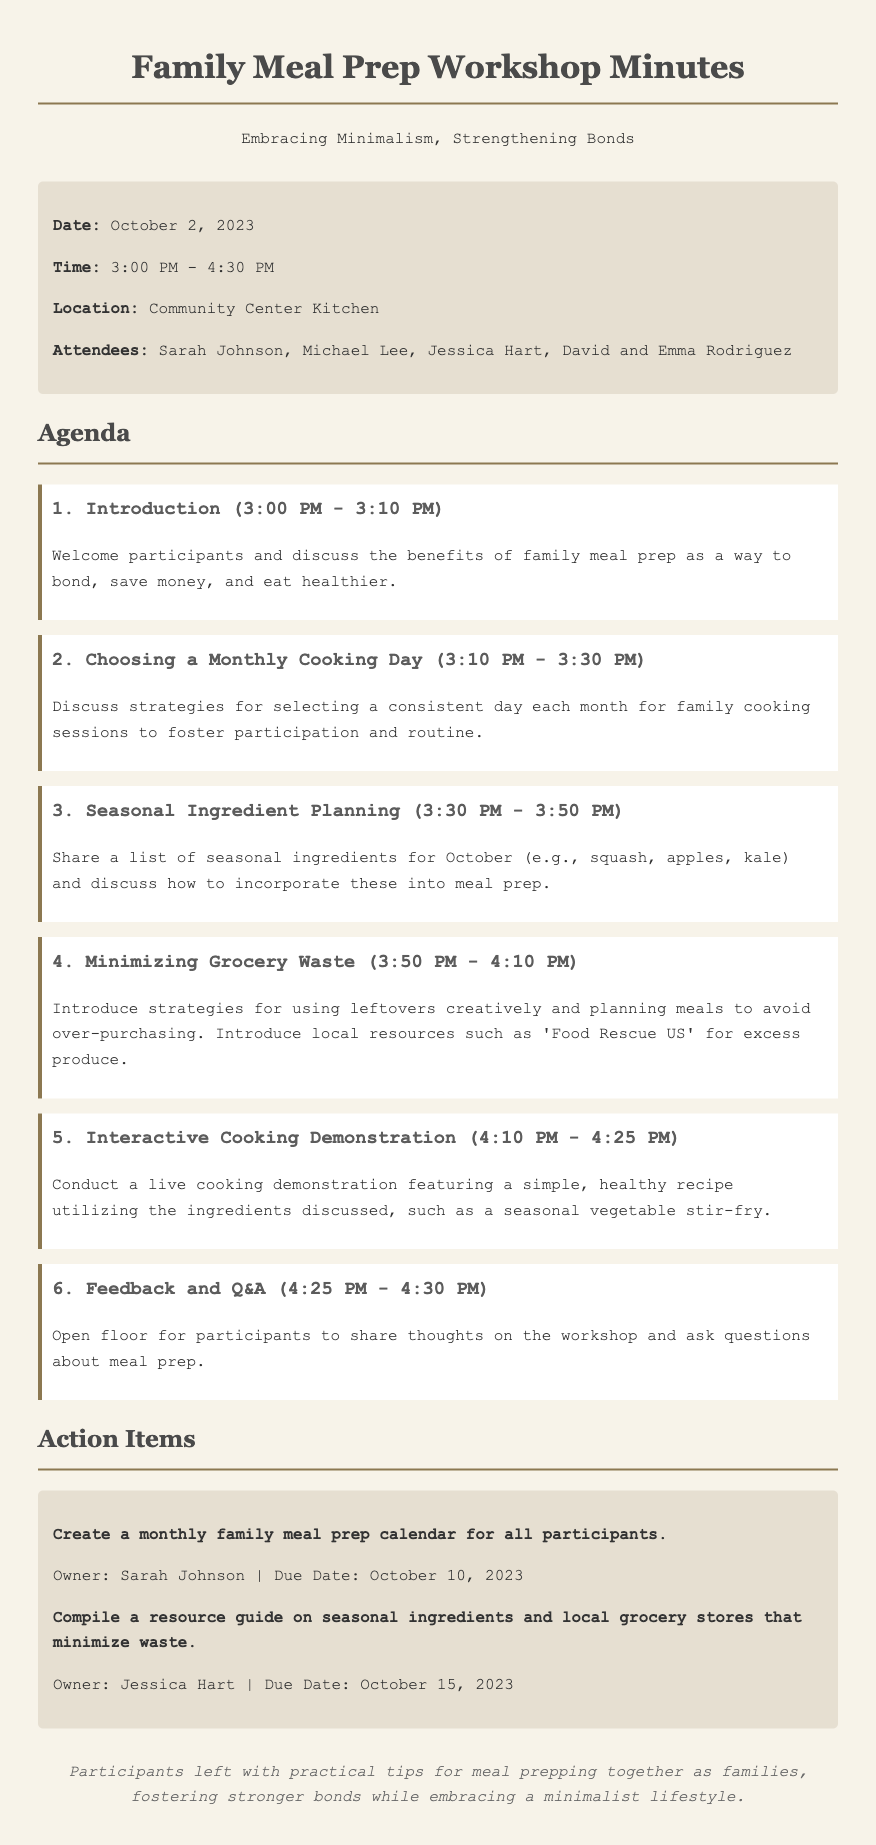what is the date of the workshop? The date of the workshop is provided in the document under the info section.
Answer: October 2, 2023 who is the owner of the action item to create a monthly family meal prep calendar? The owner of the action item is specified in the action items section.
Answer: Sarah Johnson what is one seasonal ingredient mentioned for October? The document lists seasonal ingredients during the seasonal ingredient planning agenda item.
Answer: Squash what time does the interactive cooking demonstration begin? The start time is indicated under the agenda item for the cooking demonstration.
Answer: 4:10 PM how many attendees were present at the workshop? The number of attendees is listed under the info section of the document.
Answer: Five what is the focus of the workshop? The overall purpose is discussed in the introduction section of the agenda.
Answer: Family meal prep what is the purpose of minimizing grocery waste discussed in the workshop? The document mentions strategies related to grocery waste under a specific agenda item.
Answer: Use leftovers creatively what will Jessica Hart compile as an action item? The action item is specified in the action items section detailing what Jessica Hart will do.
Answer: Resource guide on seasonal ingredients 